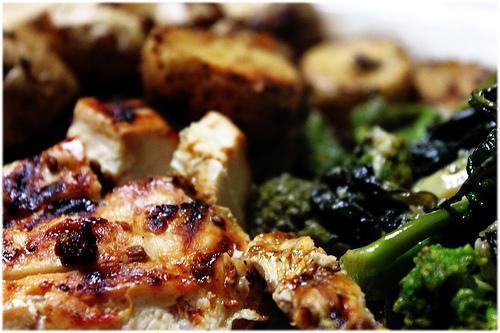How many people are visible?
Give a very brief answer. 0. 